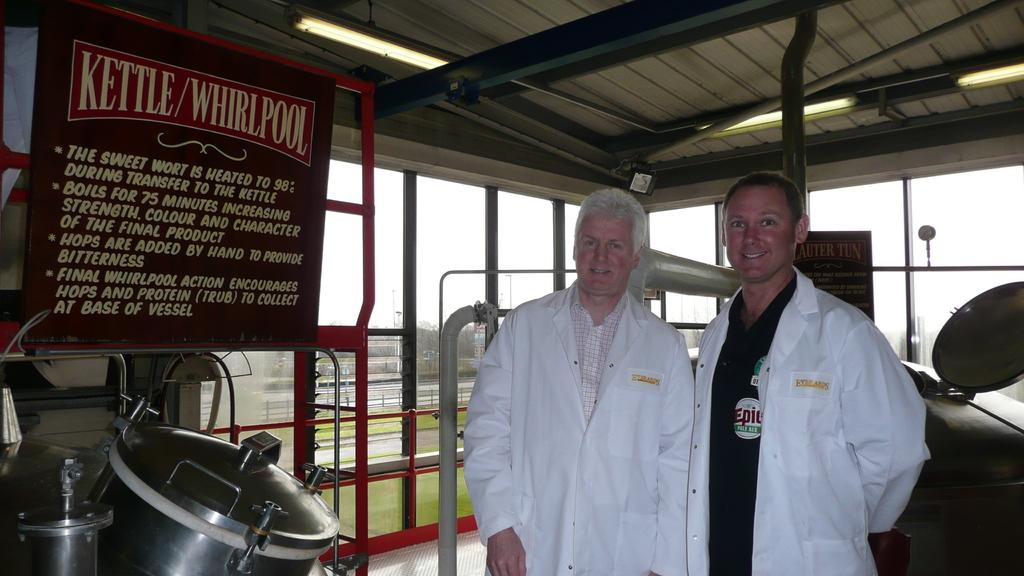<image>
Share a concise interpretation of the image provided. two men in lab coats standing in front of a sign with the words "KETTLE/WHIRLPOOL" in large letters at the top 